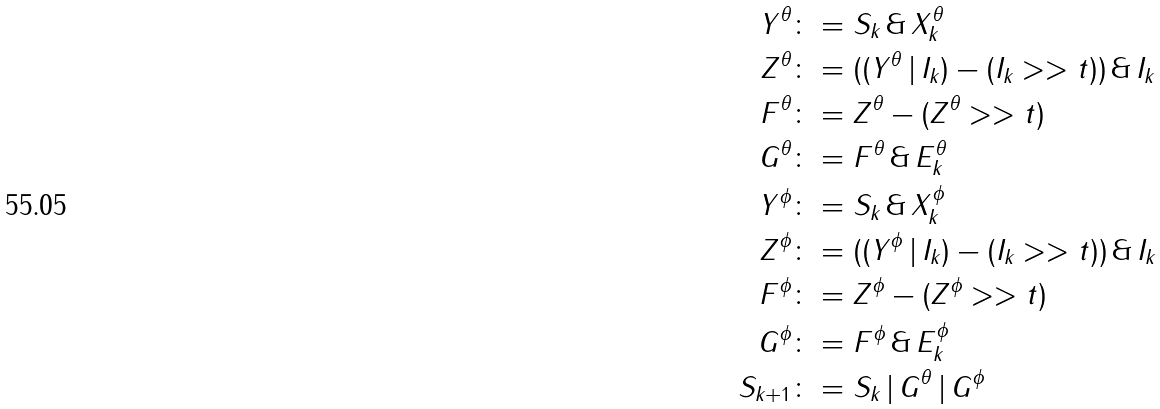<formula> <loc_0><loc_0><loc_500><loc_500>Y ^ { \theta } & \colon = S _ { k } \, \& \, X ^ { \theta } _ { k } \\ Z ^ { \theta } & \colon = ( ( Y ^ { \theta } \, | \, I _ { k } ) - ( I _ { k } > > t ) ) \, \& \, I _ { k } \\ F ^ { \theta } & \colon = Z ^ { \theta } - ( Z ^ { \theta } > > t ) \\ G ^ { \theta } & \colon = F ^ { \theta } \, \& \, E ^ { \theta } _ { k } \\ Y ^ { \phi } & \colon = S _ { k } \, \& \, X ^ { \phi } _ { k } \\ Z ^ { \phi } & \colon = ( ( Y ^ { \phi } \, | \, I _ { k } ) - ( I _ { k } > > t ) ) \, \& \, I _ { k } \\ F ^ { \phi } & \colon = Z ^ { \phi } - ( Z ^ { \phi } > > t ) \\ G ^ { \phi } & \colon = F ^ { \phi } \, \& \, E ^ { \phi } _ { k } \\ S _ { k + 1 } & \colon = S _ { k } \, | \, G ^ { \theta } \, | \, G ^ { \phi }</formula> 